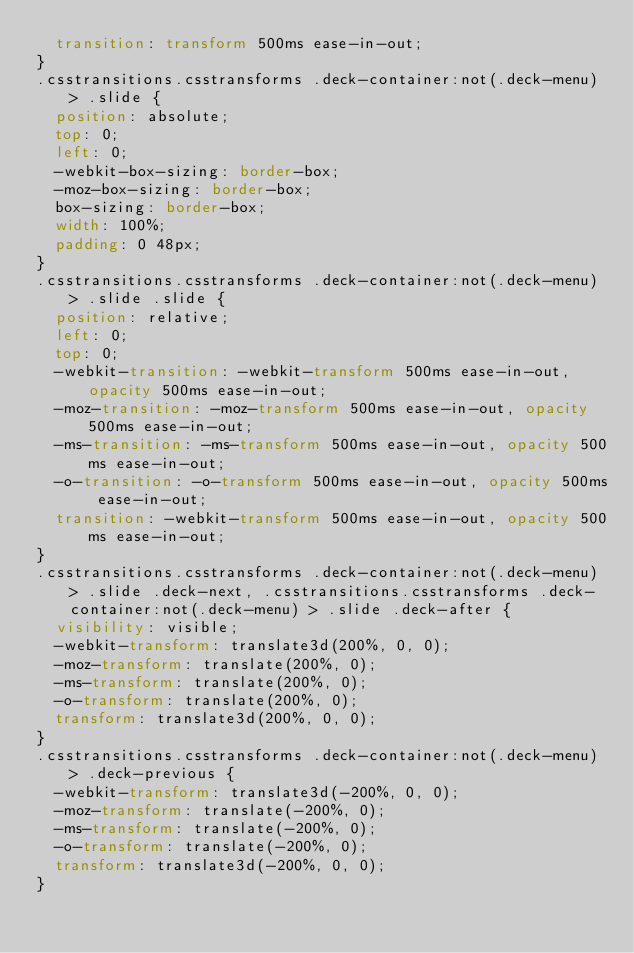<code> <loc_0><loc_0><loc_500><loc_500><_CSS_>  transition: transform 500ms ease-in-out;
}
.csstransitions.csstransforms .deck-container:not(.deck-menu) > .slide {
  position: absolute;
  top: 0;
  left: 0;
  -webkit-box-sizing: border-box;
  -moz-box-sizing: border-box;
  box-sizing: border-box;
  width: 100%;
  padding: 0 48px;
}
.csstransitions.csstransforms .deck-container:not(.deck-menu) > .slide .slide {
  position: relative;
  left: 0;
  top: 0;
  -webkit-transition: -webkit-transform 500ms ease-in-out, opacity 500ms ease-in-out;
  -moz-transition: -moz-transform 500ms ease-in-out, opacity 500ms ease-in-out;
  -ms-transition: -ms-transform 500ms ease-in-out, opacity 500ms ease-in-out;
  -o-transition: -o-transform 500ms ease-in-out, opacity 500ms ease-in-out;
  transition: -webkit-transform 500ms ease-in-out, opacity 500ms ease-in-out;
}
.csstransitions.csstransforms .deck-container:not(.deck-menu) > .slide .deck-next, .csstransitions.csstransforms .deck-container:not(.deck-menu) > .slide .deck-after {
  visibility: visible;
  -webkit-transform: translate3d(200%, 0, 0);
  -moz-transform: translate(200%, 0);
  -ms-transform: translate(200%, 0);
  -o-transform: translate(200%, 0);
  transform: translate3d(200%, 0, 0);
}
.csstransitions.csstransforms .deck-container:not(.deck-menu) > .deck-previous {
  -webkit-transform: translate3d(-200%, 0, 0);
  -moz-transform: translate(-200%, 0);
  -ms-transform: translate(-200%, 0);
  -o-transform: translate(-200%, 0);
  transform: translate3d(-200%, 0, 0);
}</code> 